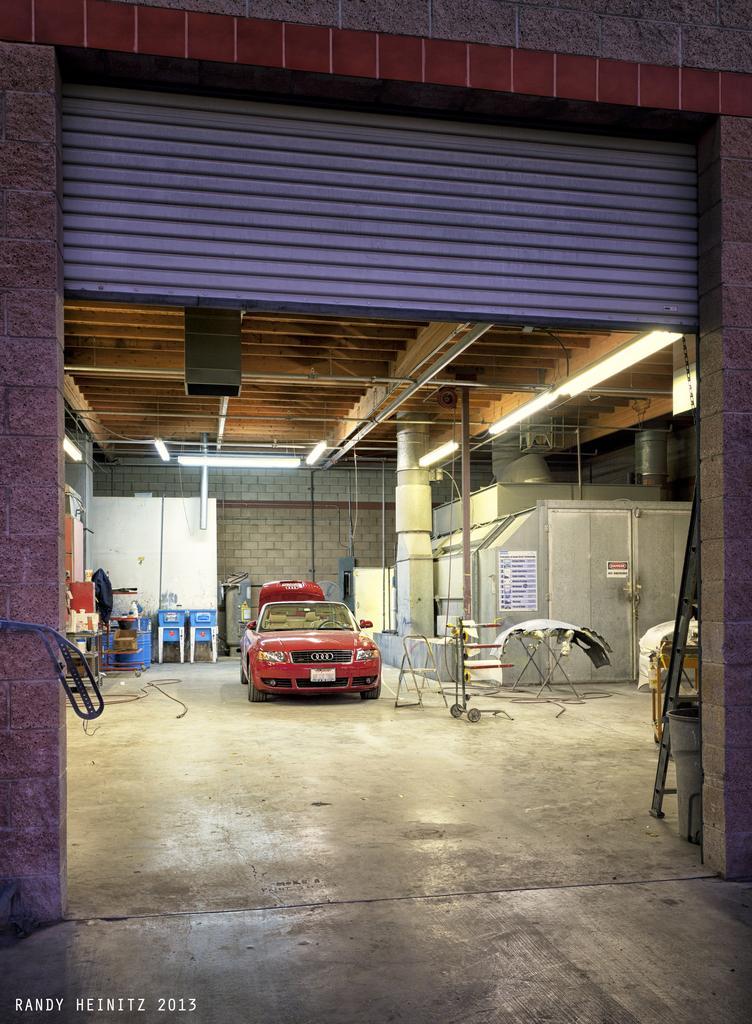Could you give a brief overview of what you see in this image? In this image I can see a vehicle which is in red color. Background I can see two chairs in blue color, wall in white color. I can also see few lights. 